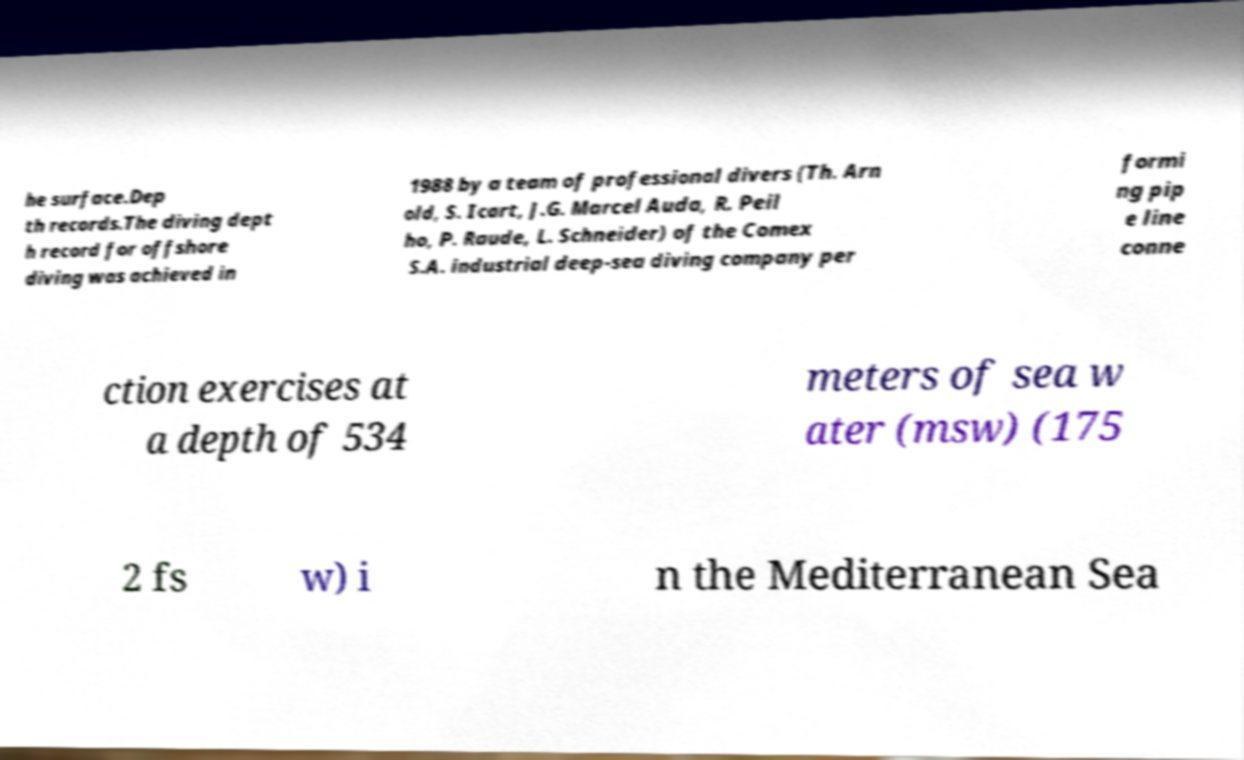I need the written content from this picture converted into text. Can you do that? he surface.Dep th records.The diving dept h record for offshore diving was achieved in 1988 by a team of professional divers (Th. Arn old, S. Icart, J.G. Marcel Auda, R. Peil ho, P. Raude, L. Schneider) of the Comex S.A. industrial deep-sea diving company per formi ng pip e line conne ction exercises at a depth of 534 meters of sea w ater (msw) (175 2 fs w) i n the Mediterranean Sea 